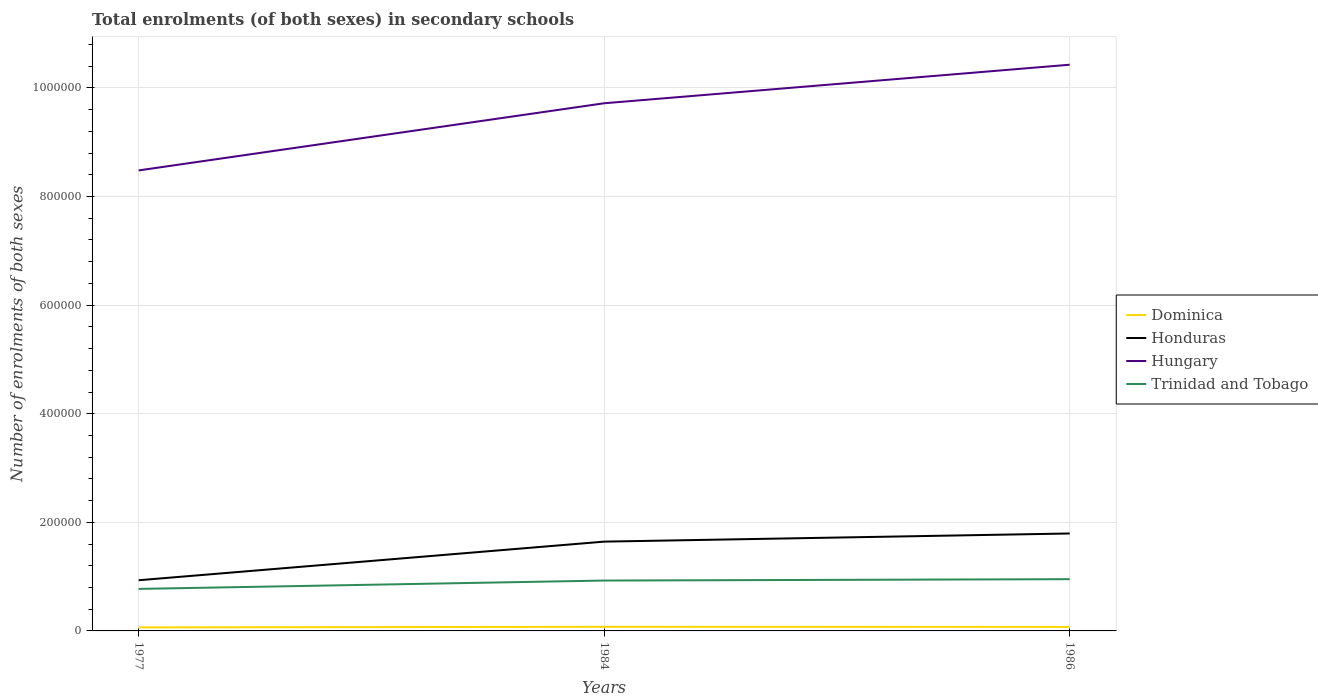Is the number of lines equal to the number of legend labels?
Make the answer very short. Yes. Across all years, what is the maximum number of enrolments in secondary schools in Honduras?
Make the answer very short. 9.33e+04. What is the total number of enrolments in secondary schools in Trinidad and Tobago in the graph?
Your response must be concise. -1.54e+04. What is the difference between the highest and the second highest number of enrolments in secondary schools in Dominica?
Your answer should be compact. 1046. How many years are there in the graph?
Ensure brevity in your answer.  3. What is the difference between two consecutive major ticks on the Y-axis?
Make the answer very short. 2.00e+05. Are the values on the major ticks of Y-axis written in scientific E-notation?
Offer a terse response. No. Does the graph contain any zero values?
Your response must be concise. No. Where does the legend appear in the graph?
Ensure brevity in your answer.  Center right. How are the legend labels stacked?
Your answer should be very brief. Vertical. What is the title of the graph?
Offer a terse response. Total enrolments (of both sexes) in secondary schools. What is the label or title of the Y-axis?
Offer a terse response. Number of enrolments of both sexes. What is the Number of enrolments of both sexes in Dominica in 1977?
Provide a succinct answer. 6516. What is the Number of enrolments of both sexes of Honduras in 1977?
Make the answer very short. 9.33e+04. What is the Number of enrolments of both sexes of Hungary in 1977?
Keep it short and to the point. 8.48e+05. What is the Number of enrolments of both sexes of Trinidad and Tobago in 1977?
Keep it short and to the point. 7.74e+04. What is the Number of enrolments of both sexes in Dominica in 1984?
Offer a very short reply. 7562. What is the Number of enrolments of both sexes of Honduras in 1984?
Your answer should be compact. 1.64e+05. What is the Number of enrolments of both sexes in Hungary in 1984?
Keep it short and to the point. 9.72e+05. What is the Number of enrolments of both sexes of Trinidad and Tobago in 1984?
Give a very brief answer. 9.28e+04. What is the Number of enrolments of both sexes of Dominica in 1986?
Provide a short and direct response. 7370. What is the Number of enrolments of both sexes of Honduras in 1986?
Provide a succinct answer. 1.79e+05. What is the Number of enrolments of both sexes in Hungary in 1986?
Your response must be concise. 1.04e+06. What is the Number of enrolments of both sexes of Trinidad and Tobago in 1986?
Give a very brief answer. 9.53e+04. Across all years, what is the maximum Number of enrolments of both sexes in Dominica?
Offer a very short reply. 7562. Across all years, what is the maximum Number of enrolments of both sexes of Honduras?
Give a very brief answer. 1.79e+05. Across all years, what is the maximum Number of enrolments of both sexes in Hungary?
Offer a terse response. 1.04e+06. Across all years, what is the maximum Number of enrolments of both sexes of Trinidad and Tobago?
Your answer should be compact. 9.53e+04. Across all years, what is the minimum Number of enrolments of both sexes in Dominica?
Provide a short and direct response. 6516. Across all years, what is the minimum Number of enrolments of both sexes of Honduras?
Give a very brief answer. 9.33e+04. Across all years, what is the minimum Number of enrolments of both sexes in Hungary?
Ensure brevity in your answer.  8.48e+05. Across all years, what is the minimum Number of enrolments of both sexes in Trinidad and Tobago?
Provide a short and direct response. 7.74e+04. What is the total Number of enrolments of both sexes of Dominica in the graph?
Your response must be concise. 2.14e+04. What is the total Number of enrolments of both sexes of Honduras in the graph?
Your response must be concise. 4.37e+05. What is the total Number of enrolments of both sexes of Hungary in the graph?
Provide a short and direct response. 2.86e+06. What is the total Number of enrolments of both sexes in Trinidad and Tobago in the graph?
Your response must be concise. 2.65e+05. What is the difference between the Number of enrolments of both sexes of Dominica in 1977 and that in 1984?
Provide a short and direct response. -1046. What is the difference between the Number of enrolments of both sexes in Honduras in 1977 and that in 1984?
Make the answer very short. -7.11e+04. What is the difference between the Number of enrolments of both sexes in Hungary in 1977 and that in 1984?
Ensure brevity in your answer.  -1.24e+05. What is the difference between the Number of enrolments of both sexes in Trinidad and Tobago in 1977 and that in 1984?
Offer a terse response. -1.54e+04. What is the difference between the Number of enrolments of both sexes of Dominica in 1977 and that in 1986?
Provide a short and direct response. -854. What is the difference between the Number of enrolments of both sexes of Honduras in 1977 and that in 1986?
Give a very brief answer. -8.61e+04. What is the difference between the Number of enrolments of both sexes of Hungary in 1977 and that in 1986?
Your response must be concise. -1.95e+05. What is the difference between the Number of enrolments of both sexes in Trinidad and Tobago in 1977 and that in 1986?
Your response must be concise. -1.79e+04. What is the difference between the Number of enrolments of both sexes of Dominica in 1984 and that in 1986?
Give a very brief answer. 192. What is the difference between the Number of enrolments of both sexes in Honduras in 1984 and that in 1986?
Your answer should be compact. -1.50e+04. What is the difference between the Number of enrolments of both sexes in Hungary in 1984 and that in 1986?
Ensure brevity in your answer.  -7.10e+04. What is the difference between the Number of enrolments of both sexes of Trinidad and Tobago in 1984 and that in 1986?
Provide a short and direct response. -2521. What is the difference between the Number of enrolments of both sexes of Dominica in 1977 and the Number of enrolments of both sexes of Honduras in 1984?
Offer a very short reply. -1.58e+05. What is the difference between the Number of enrolments of both sexes of Dominica in 1977 and the Number of enrolments of both sexes of Hungary in 1984?
Offer a terse response. -9.65e+05. What is the difference between the Number of enrolments of both sexes in Dominica in 1977 and the Number of enrolments of both sexes in Trinidad and Tobago in 1984?
Your response must be concise. -8.63e+04. What is the difference between the Number of enrolments of both sexes of Honduras in 1977 and the Number of enrolments of both sexes of Hungary in 1984?
Give a very brief answer. -8.78e+05. What is the difference between the Number of enrolments of both sexes of Honduras in 1977 and the Number of enrolments of both sexes of Trinidad and Tobago in 1984?
Provide a succinct answer. 549. What is the difference between the Number of enrolments of both sexes in Hungary in 1977 and the Number of enrolments of both sexes in Trinidad and Tobago in 1984?
Give a very brief answer. 7.55e+05. What is the difference between the Number of enrolments of both sexes of Dominica in 1977 and the Number of enrolments of both sexes of Honduras in 1986?
Make the answer very short. -1.73e+05. What is the difference between the Number of enrolments of both sexes in Dominica in 1977 and the Number of enrolments of both sexes in Hungary in 1986?
Keep it short and to the point. -1.04e+06. What is the difference between the Number of enrolments of both sexes in Dominica in 1977 and the Number of enrolments of both sexes in Trinidad and Tobago in 1986?
Make the answer very short. -8.88e+04. What is the difference between the Number of enrolments of both sexes of Honduras in 1977 and the Number of enrolments of both sexes of Hungary in 1986?
Offer a terse response. -9.49e+05. What is the difference between the Number of enrolments of both sexes in Honduras in 1977 and the Number of enrolments of both sexes in Trinidad and Tobago in 1986?
Your response must be concise. -1972. What is the difference between the Number of enrolments of both sexes of Hungary in 1977 and the Number of enrolments of both sexes of Trinidad and Tobago in 1986?
Keep it short and to the point. 7.53e+05. What is the difference between the Number of enrolments of both sexes of Dominica in 1984 and the Number of enrolments of both sexes of Honduras in 1986?
Ensure brevity in your answer.  -1.72e+05. What is the difference between the Number of enrolments of both sexes in Dominica in 1984 and the Number of enrolments of both sexes in Hungary in 1986?
Your answer should be very brief. -1.04e+06. What is the difference between the Number of enrolments of both sexes of Dominica in 1984 and the Number of enrolments of both sexes of Trinidad and Tobago in 1986?
Your answer should be very brief. -8.77e+04. What is the difference between the Number of enrolments of both sexes in Honduras in 1984 and the Number of enrolments of both sexes in Hungary in 1986?
Your answer should be very brief. -8.78e+05. What is the difference between the Number of enrolments of both sexes of Honduras in 1984 and the Number of enrolments of both sexes of Trinidad and Tobago in 1986?
Give a very brief answer. 6.92e+04. What is the difference between the Number of enrolments of both sexes in Hungary in 1984 and the Number of enrolments of both sexes in Trinidad and Tobago in 1986?
Make the answer very short. 8.76e+05. What is the average Number of enrolments of both sexes of Dominica per year?
Your response must be concise. 7149.33. What is the average Number of enrolments of both sexes in Honduras per year?
Your answer should be very brief. 1.46e+05. What is the average Number of enrolments of both sexes in Hungary per year?
Offer a very short reply. 9.54e+05. What is the average Number of enrolments of both sexes of Trinidad and Tobago per year?
Your response must be concise. 8.85e+04. In the year 1977, what is the difference between the Number of enrolments of both sexes of Dominica and Number of enrolments of both sexes of Honduras?
Keep it short and to the point. -8.68e+04. In the year 1977, what is the difference between the Number of enrolments of both sexes in Dominica and Number of enrolments of both sexes in Hungary?
Your answer should be very brief. -8.42e+05. In the year 1977, what is the difference between the Number of enrolments of both sexes in Dominica and Number of enrolments of both sexes in Trinidad and Tobago?
Keep it short and to the point. -7.08e+04. In the year 1977, what is the difference between the Number of enrolments of both sexes in Honduras and Number of enrolments of both sexes in Hungary?
Your answer should be very brief. -7.55e+05. In the year 1977, what is the difference between the Number of enrolments of both sexes in Honduras and Number of enrolments of both sexes in Trinidad and Tobago?
Give a very brief answer. 1.60e+04. In the year 1977, what is the difference between the Number of enrolments of both sexes in Hungary and Number of enrolments of both sexes in Trinidad and Tobago?
Your answer should be compact. 7.71e+05. In the year 1984, what is the difference between the Number of enrolments of both sexes of Dominica and Number of enrolments of both sexes of Honduras?
Offer a very short reply. -1.57e+05. In the year 1984, what is the difference between the Number of enrolments of both sexes of Dominica and Number of enrolments of both sexes of Hungary?
Keep it short and to the point. -9.64e+05. In the year 1984, what is the difference between the Number of enrolments of both sexes of Dominica and Number of enrolments of both sexes of Trinidad and Tobago?
Keep it short and to the point. -8.52e+04. In the year 1984, what is the difference between the Number of enrolments of both sexes of Honduras and Number of enrolments of both sexes of Hungary?
Your answer should be compact. -8.07e+05. In the year 1984, what is the difference between the Number of enrolments of both sexes in Honduras and Number of enrolments of both sexes in Trinidad and Tobago?
Your response must be concise. 7.17e+04. In the year 1984, what is the difference between the Number of enrolments of both sexes in Hungary and Number of enrolments of both sexes in Trinidad and Tobago?
Your answer should be very brief. 8.79e+05. In the year 1986, what is the difference between the Number of enrolments of both sexes in Dominica and Number of enrolments of both sexes in Honduras?
Make the answer very short. -1.72e+05. In the year 1986, what is the difference between the Number of enrolments of both sexes in Dominica and Number of enrolments of both sexes in Hungary?
Your answer should be compact. -1.04e+06. In the year 1986, what is the difference between the Number of enrolments of both sexes in Dominica and Number of enrolments of both sexes in Trinidad and Tobago?
Give a very brief answer. -8.79e+04. In the year 1986, what is the difference between the Number of enrolments of both sexes in Honduras and Number of enrolments of both sexes in Hungary?
Give a very brief answer. -8.63e+05. In the year 1986, what is the difference between the Number of enrolments of both sexes in Honduras and Number of enrolments of both sexes in Trinidad and Tobago?
Make the answer very short. 8.41e+04. In the year 1986, what is the difference between the Number of enrolments of both sexes in Hungary and Number of enrolments of both sexes in Trinidad and Tobago?
Your answer should be very brief. 9.47e+05. What is the ratio of the Number of enrolments of both sexes of Dominica in 1977 to that in 1984?
Your response must be concise. 0.86. What is the ratio of the Number of enrolments of both sexes of Honduras in 1977 to that in 1984?
Keep it short and to the point. 0.57. What is the ratio of the Number of enrolments of both sexes in Hungary in 1977 to that in 1984?
Keep it short and to the point. 0.87. What is the ratio of the Number of enrolments of both sexes of Trinidad and Tobago in 1977 to that in 1984?
Provide a succinct answer. 0.83. What is the ratio of the Number of enrolments of both sexes of Dominica in 1977 to that in 1986?
Offer a very short reply. 0.88. What is the ratio of the Number of enrolments of both sexes of Honduras in 1977 to that in 1986?
Provide a short and direct response. 0.52. What is the ratio of the Number of enrolments of both sexes in Hungary in 1977 to that in 1986?
Provide a succinct answer. 0.81. What is the ratio of the Number of enrolments of both sexes of Trinidad and Tobago in 1977 to that in 1986?
Make the answer very short. 0.81. What is the ratio of the Number of enrolments of both sexes of Dominica in 1984 to that in 1986?
Your answer should be very brief. 1.03. What is the ratio of the Number of enrolments of both sexes in Honduras in 1984 to that in 1986?
Offer a terse response. 0.92. What is the ratio of the Number of enrolments of both sexes of Hungary in 1984 to that in 1986?
Offer a very short reply. 0.93. What is the ratio of the Number of enrolments of both sexes in Trinidad and Tobago in 1984 to that in 1986?
Your answer should be compact. 0.97. What is the difference between the highest and the second highest Number of enrolments of both sexes of Dominica?
Your response must be concise. 192. What is the difference between the highest and the second highest Number of enrolments of both sexes of Honduras?
Offer a terse response. 1.50e+04. What is the difference between the highest and the second highest Number of enrolments of both sexes in Hungary?
Offer a very short reply. 7.10e+04. What is the difference between the highest and the second highest Number of enrolments of both sexes of Trinidad and Tobago?
Provide a short and direct response. 2521. What is the difference between the highest and the lowest Number of enrolments of both sexes in Dominica?
Your answer should be compact. 1046. What is the difference between the highest and the lowest Number of enrolments of both sexes in Honduras?
Offer a terse response. 8.61e+04. What is the difference between the highest and the lowest Number of enrolments of both sexes in Hungary?
Provide a short and direct response. 1.95e+05. What is the difference between the highest and the lowest Number of enrolments of both sexes in Trinidad and Tobago?
Make the answer very short. 1.79e+04. 